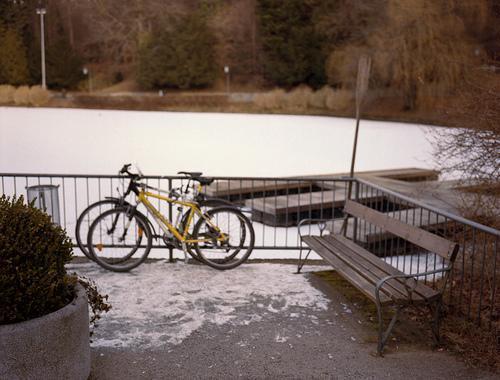How many bikes are there?
Give a very brief answer. 2. 